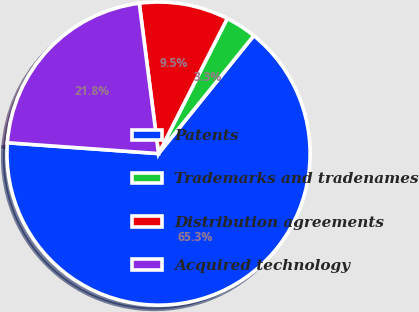Convert chart to OTSL. <chart><loc_0><loc_0><loc_500><loc_500><pie_chart><fcel>Patents<fcel>Trademarks and tradenames<fcel>Distribution agreements<fcel>Acquired technology<nl><fcel>65.33%<fcel>3.32%<fcel>9.52%<fcel>21.83%<nl></chart> 